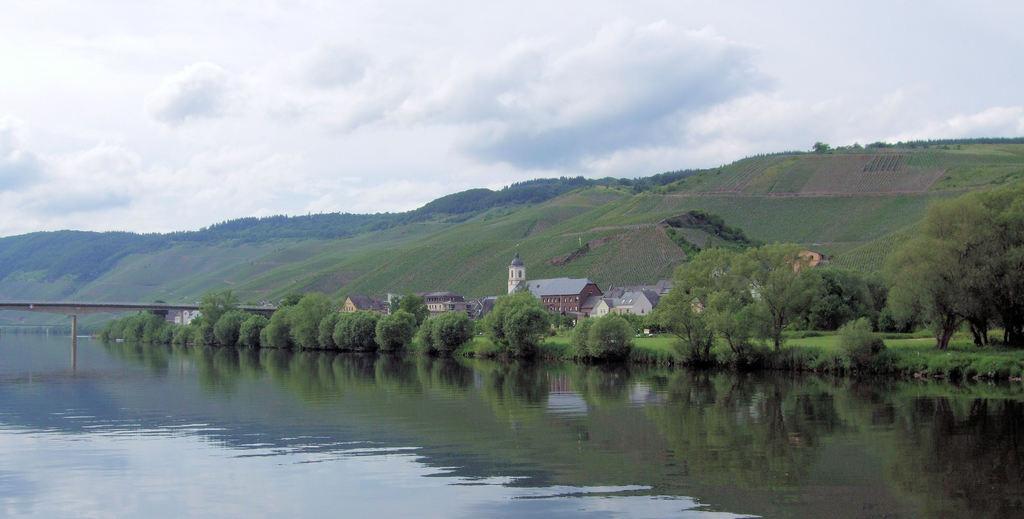Describe this image in one or two sentences. In this image at the bottom there is a river and in the center there is a bridge and some buildings, trees and grass. In the background there are some mountains, and at the top of the image there is sky. 